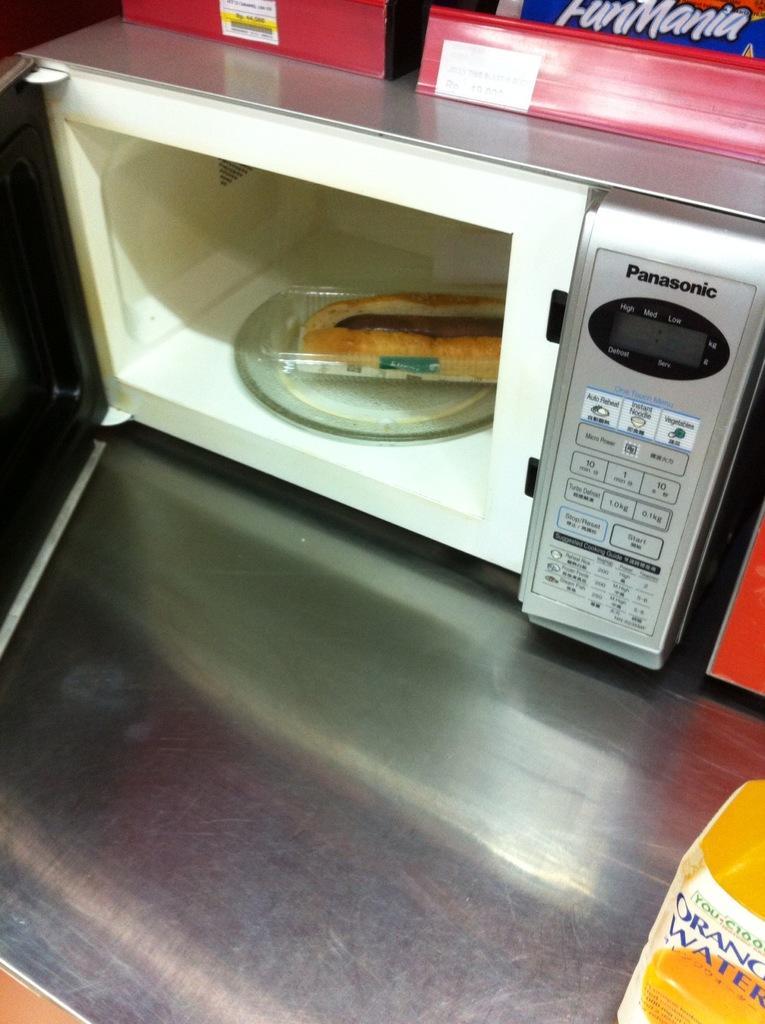Could you give a brief overview of what you see in this image? In this image there is a Panasonic oven and inside the oven we can see a food item. The oven is placed on the counter. Image also consists of two red color boxes at the top. 